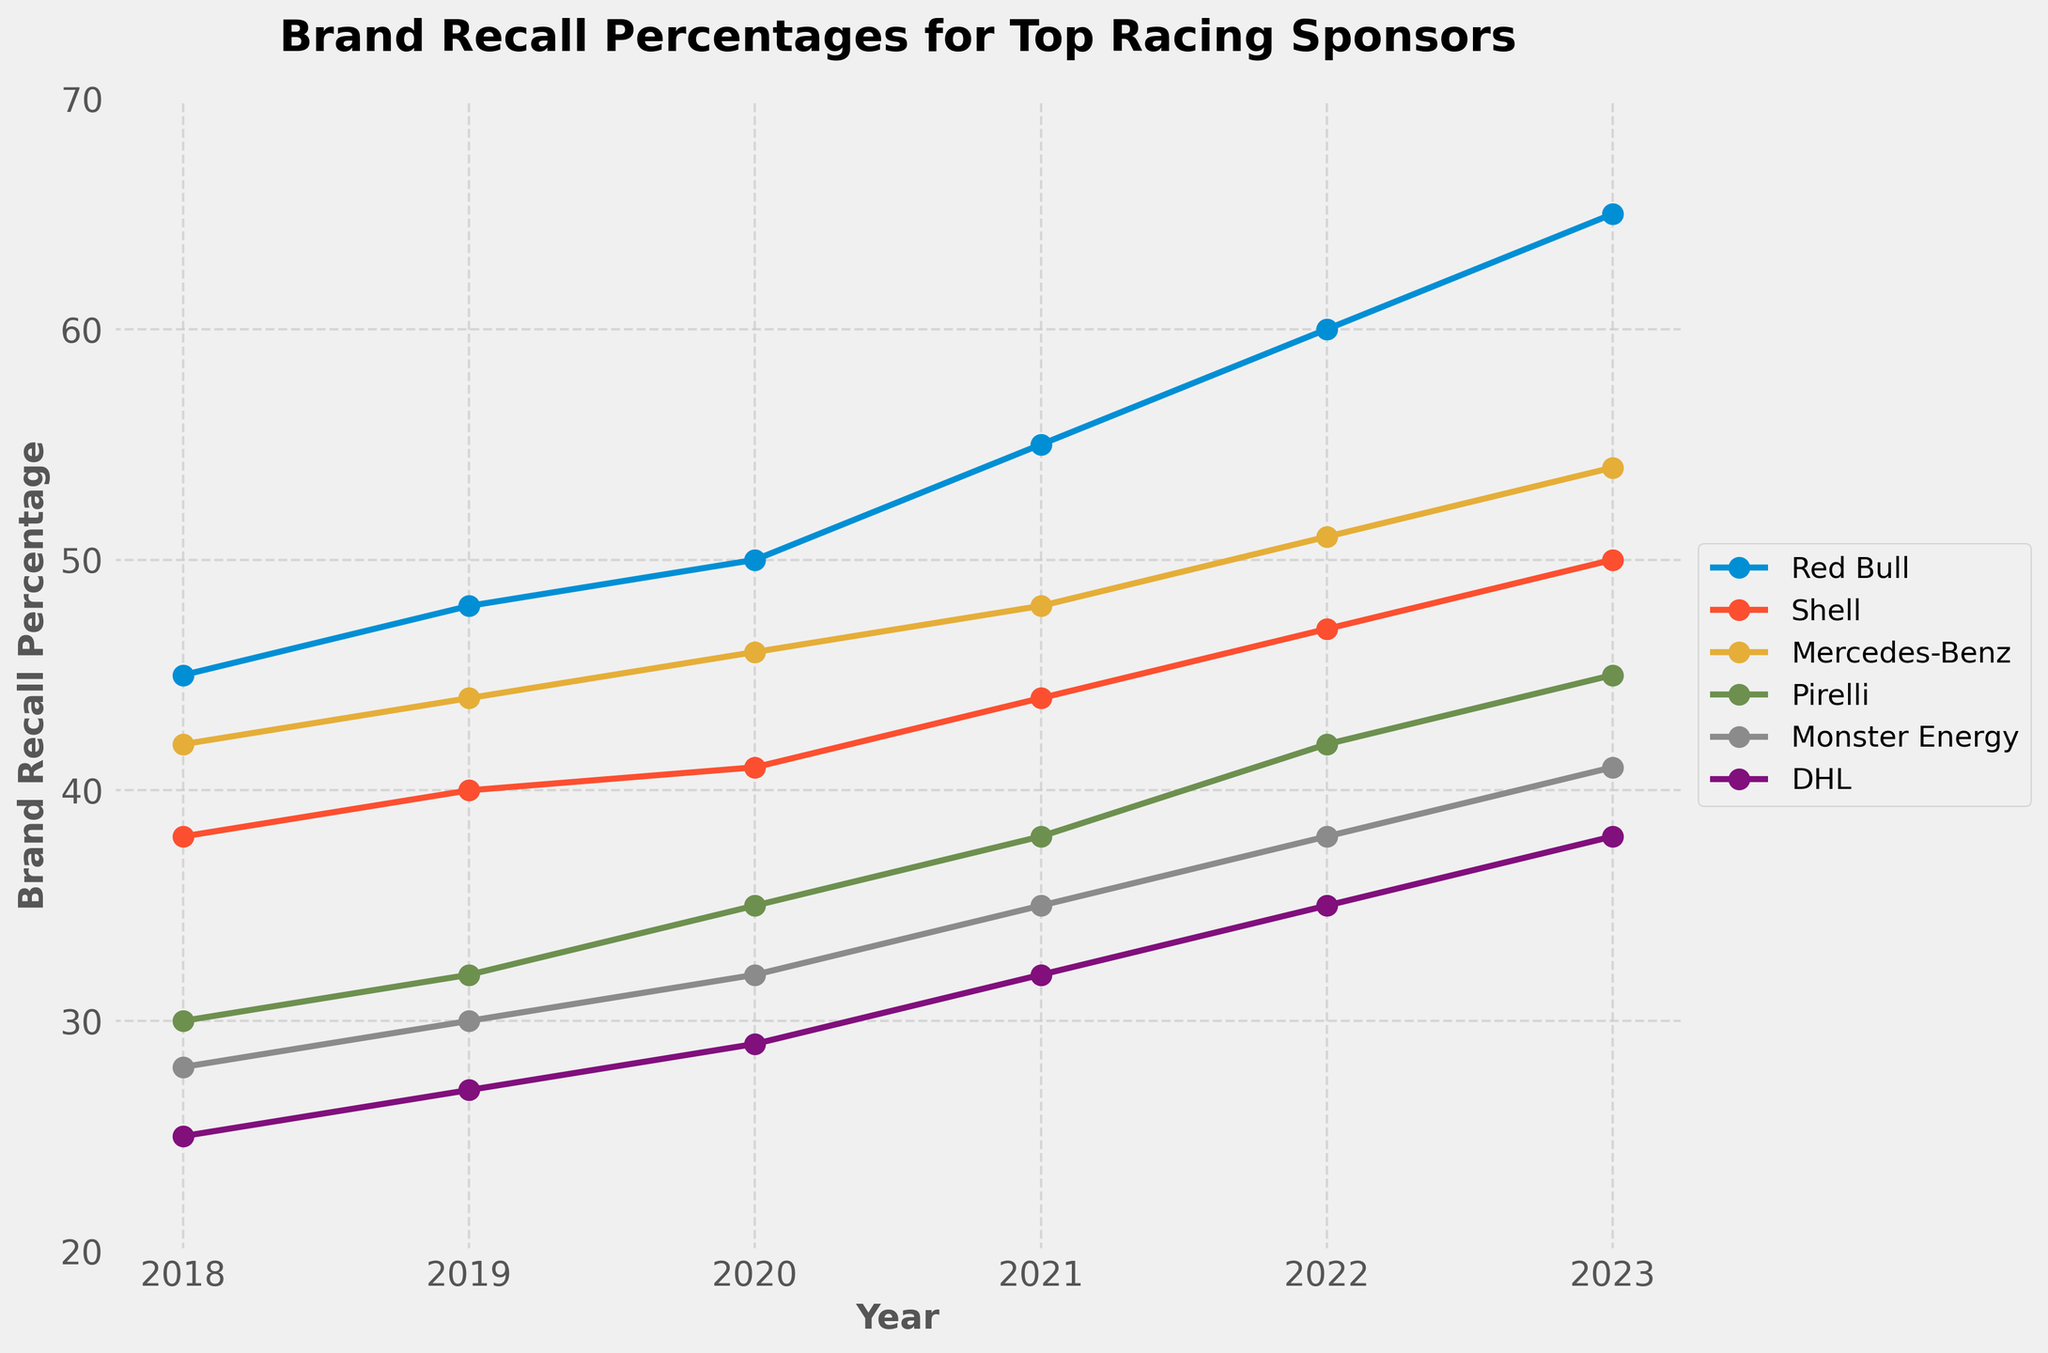What's the average brand recall percentage for Mercedes-Benz over the years? The data shows the brand recall percentages for Mercedes-Benz from 2018 to 2023. By adding these values (42 + 44 + 46 + 48 + 51 + 54) and dividing by the number of years (6), we get the average: (285 / 6) = 47.5
Answer: 47.5 Between 2018 and 2023, which sponsor showed the highest increase in brand recall percentage? To determine the highest increase, we need to calculate the difference between the 2023 and 2018 percentages for each sponsor: Red Bull (65 - 45 = 20), Shell (50 - 38 = 12), Mercedes-Benz (54 - 42 = 12), Pirelli (45 - 30 = 15), Monster Energy (41 - 28 = 13), and DHL (38 - 25 = 13). Red Bull shows the highest increase of 20.
Answer: Red Bull Which year did Monster Energy surpass DHL in brand recall? We can compare the brand recall percentages of Monster Energy and DHL year by year: 
2018: 28 (Monster Energy) vs. 25 (DHL) - Monster Energy > DHL,
2019: 30 vs. 27 - Monster Energy > DHL,
2020: 32 vs. 29 - Monster Energy > DHL,
2021: 35 vs. 32 - Monster Energy > DHL,
2022: 38 vs. 35 - Monster Energy > DHL,
2023: 41 vs. 38 - Monster Energy > DHL.
Monster Energy surpassed DHL in 2018 itself and maintained this lead each year.
Answer: 2018 What was the total brand recall percentage for all sponsors combined in 2021? To find the total, we sum the brand recall percentages for all sponsors in 2021: 55 (Red Bull) + 44 (Shell) + 48 (Mercedes-Benz) + 38 (Pirelli) + 35 (Monster Energy) + 32 (DHL) = 252.
Answer: 252 Which sponsor had the lowest brand recall percentage in 2019, and what was it? By checking the values for 2019, the lowest brand recall percentage is for DHL at 27.
Answer: DHL, 27 Compare the trend lines for Red Bull and Pirelli. How do their trends in brand recall percentage differ from 2018 to 2023? Red Bull shows a consistent and steep upward trend, starting from 45 in 2018 and increasing to 65 in 2023. Pirelli also shows an upward trend but at a slower rate, starting from 30 in 2018 and increasing to 45 in 2023. Red Bull's increase is more pronounced compared to Pirelli.
Answer: Red Bull has a steeper upward trend compared to Pirelli What's the difference in brand recall percentage between Shell and Monster Energy for the year 2022? Check the values for Shell and Monster Energy in 2022: Shell (47) and Monster Energy (38). The difference is 47 - 38 = 9.
Answer: 9 What was the highest brand recall percentage achieved by any sponsor during these years? Reviewing the data, the highest brand recall percentage achieved is by Red Bull in 2023 at 65.
Answer: 65 How did DHL's brand recall percentage change over the 6-year period? DHL's brand recall percentage increased from 25 in 2018 to 38 in 2023. The change is 38 - 25 = 13.
Answer: 13 